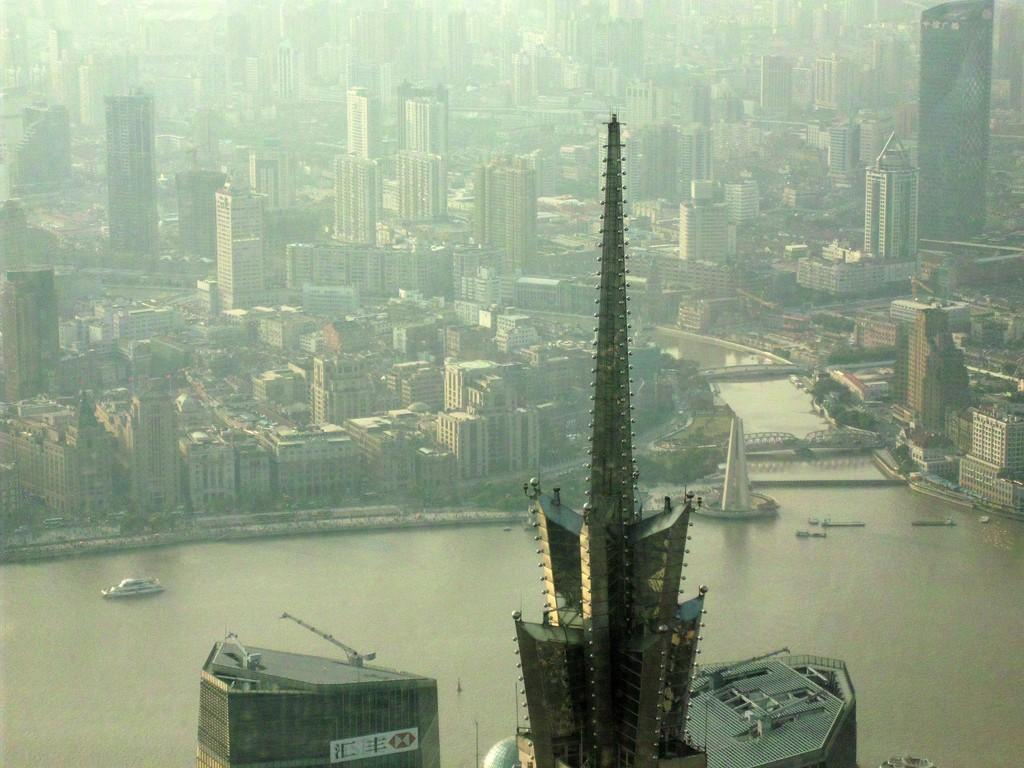What is the primary element in the image? There is water in the image. What structures can be seen in the image? There are buildings visible in the image. What type of vehicles are present in the water? There are boats in the water. Is there any man-made structure connecting the two sides of the water? Yes, there is a bridge in the image. Can you confirm the presence of trees in the image? The facts do not explicitly confirm the presence of trees, but they may be present. What type of creature is using the camera to take a picture of the boats in the image? There is no creature or camera present in the image; it only features water, buildings, boats, and a bridge. How many frogs can be seen hopping on the bridge in the image? There are no frogs present in the image; it only features water, buildings, boats, and a bridge. 